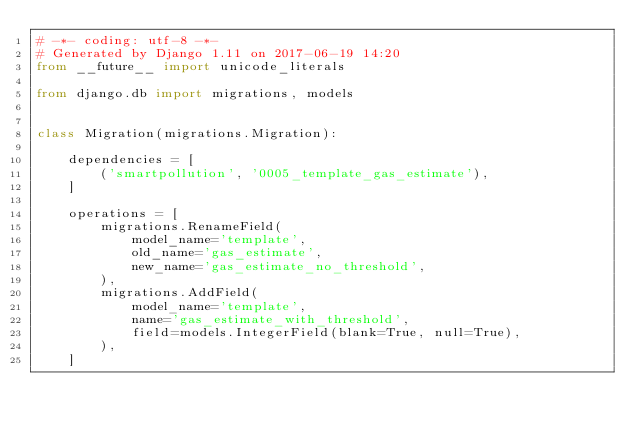Convert code to text. <code><loc_0><loc_0><loc_500><loc_500><_Python_># -*- coding: utf-8 -*-
# Generated by Django 1.11 on 2017-06-19 14:20
from __future__ import unicode_literals

from django.db import migrations, models


class Migration(migrations.Migration):

    dependencies = [
        ('smartpollution', '0005_template_gas_estimate'),
    ]

    operations = [
        migrations.RenameField(
            model_name='template',
            old_name='gas_estimate',
            new_name='gas_estimate_no_threshold',
        ),
        migrations.AddField(
            model_name='template',
            name='gas_estimate_with_threshold',
            field=models.IntegerField(blank=True, null=True),
        ),
    ]
</code> 